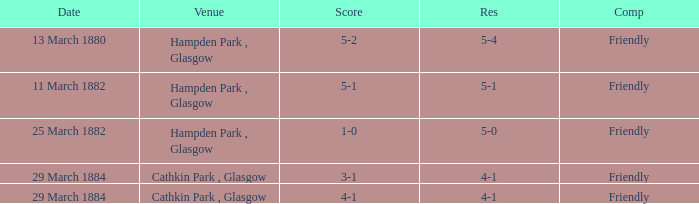Which competition had a 4-1 result, and a score of 4-1? Friendly. Give me the full table as a dictionary. {'header': ['Date', 'Venue', 'Score', 'Res', 'Comp'], 'rows': [['13 March 1880', 'Hampden Park , Glasgow', '5-2', '5-4', 'Friendly'], ['11 March 1882', 'Hampden Park , Glasgow', '5-1', '5-1', 'Friendly'], ['25 March 1882', 'Hampden Park , Glasgow', '1-0', '5-0', 'Friendly'], ['29 March 1884', 'Cathkin Park , Glasgow', '3-1', '4-1', 'Friendly'], ['29 March 1884', 'Cathkin Park , Glasgow', '4-1', '4-1', 'Friendly']]} 